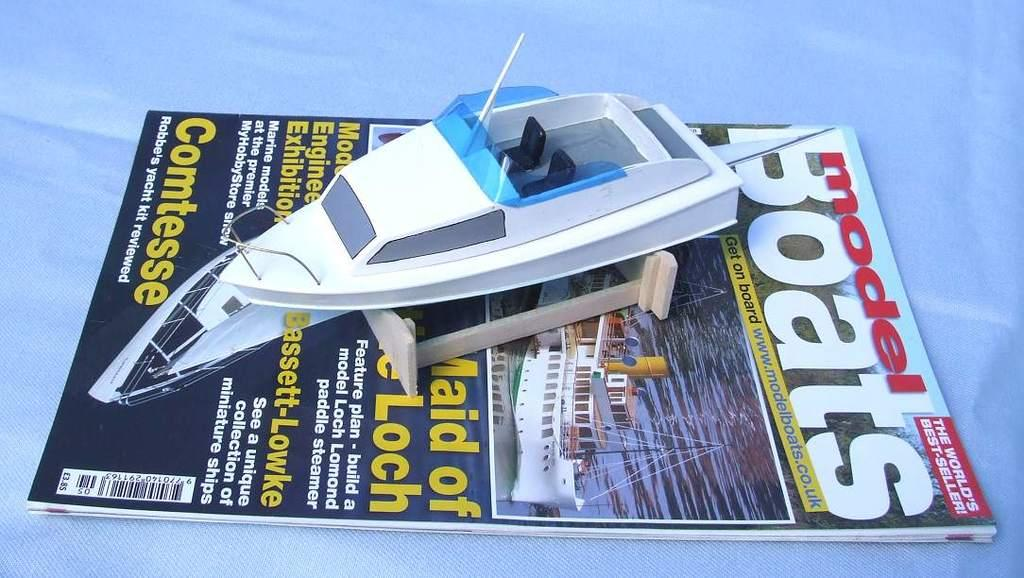<image>
Summarize the visual content of the image. A magazine for Model Boats has a real model boat on top of it. 